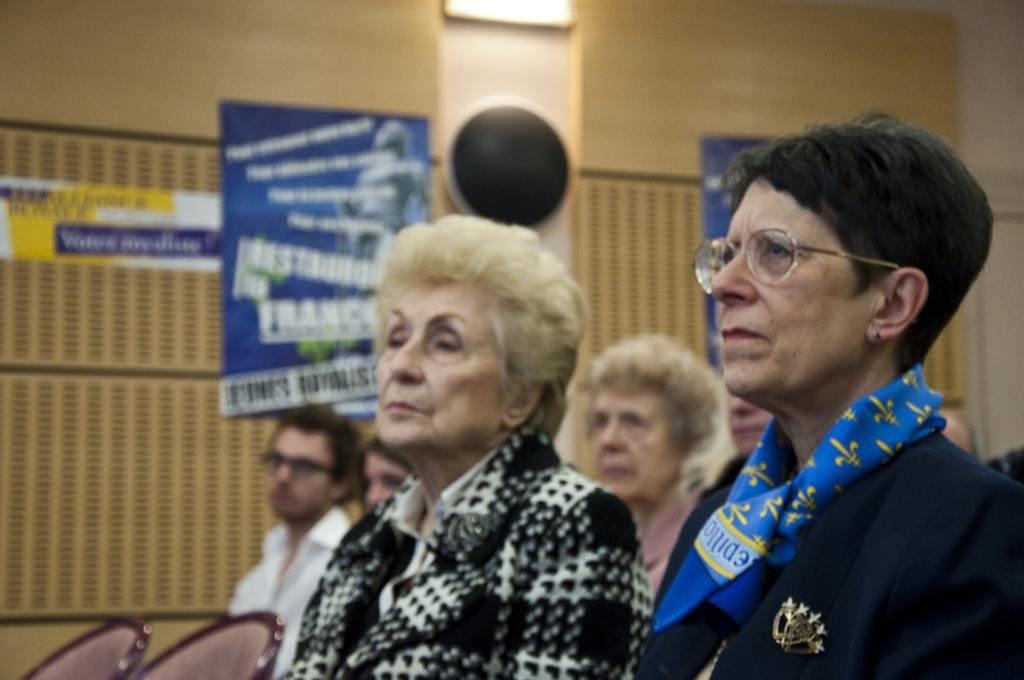What is located in the foreground of the image? There are people in the foreground of the image. What can be seen in the background of the image? There are posters attached to the wall in the background of the image. What type of wood can be seen in the image? There is no wood visible in the image; it features people in the foreground and posters on the wall in the background. Can you hear the voice of the judge in the image? There is no judge or voice present in the image. 